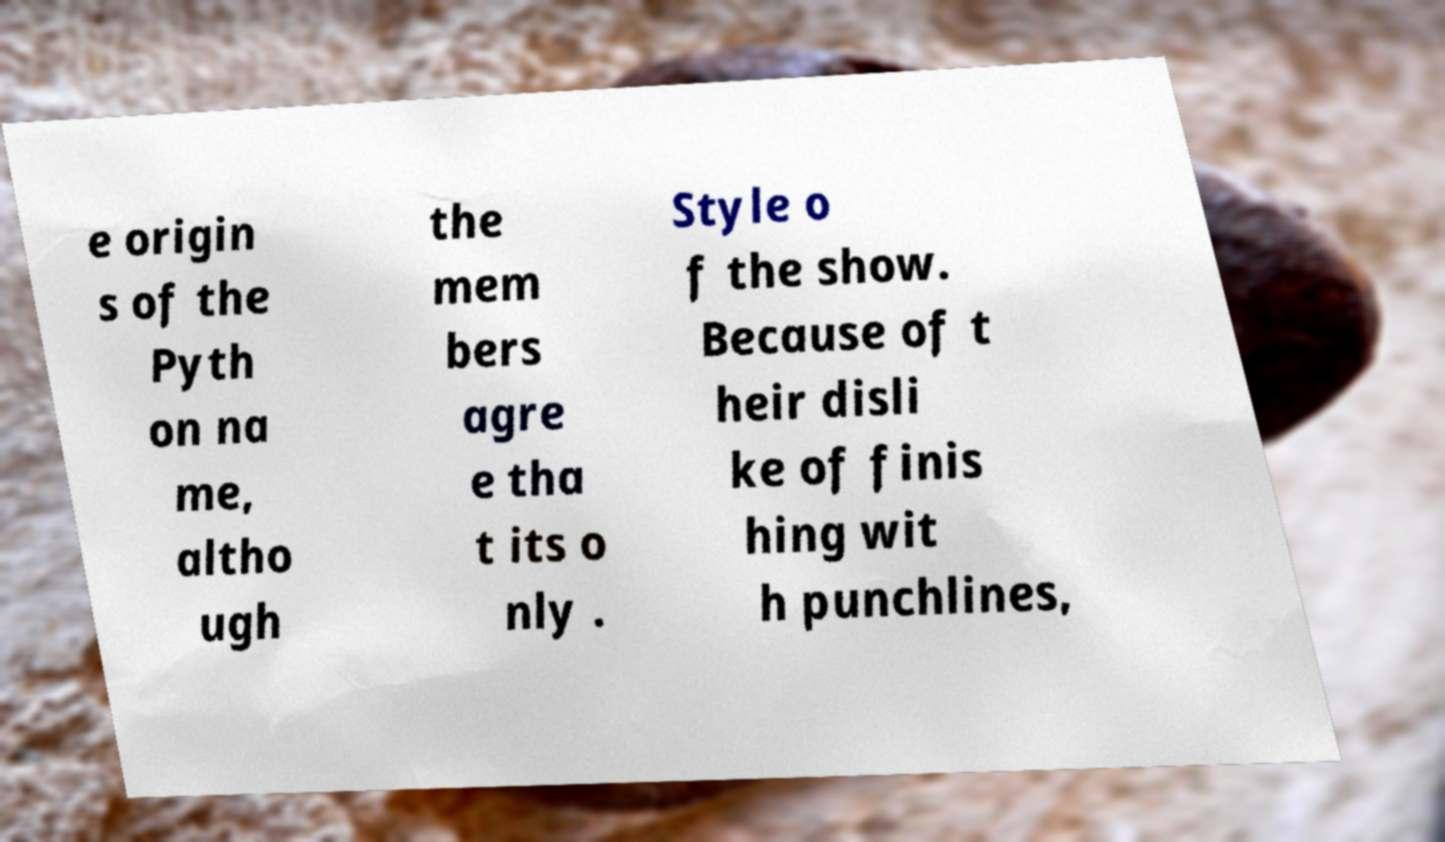For documentation purposes, I need the text within this image transcribed. Could you provide that? e origin s of the Pyth on na me, altho ugh the mem bers agre e tha t its o nly . Style o f the show. Because of t heir disli ke of finis hing wit h punchlines, 